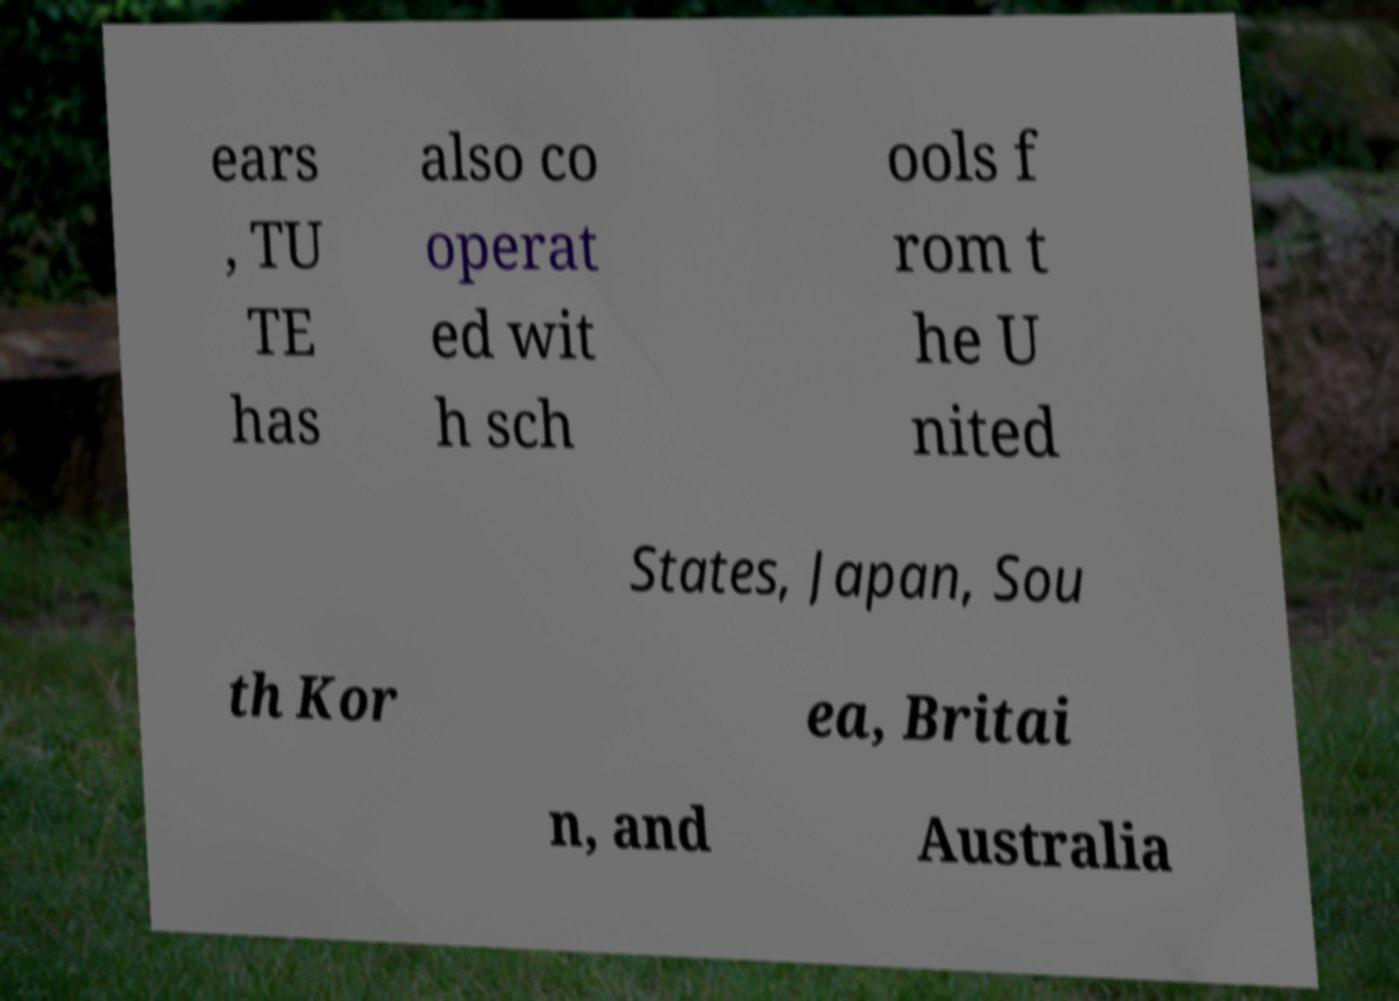Could you extract and type out the text from this image? ears , TU TE has also co operat ed wit h sch ools f rom t he U nited States, Japan, Sou th Kor ea, Britai n, and Australia 